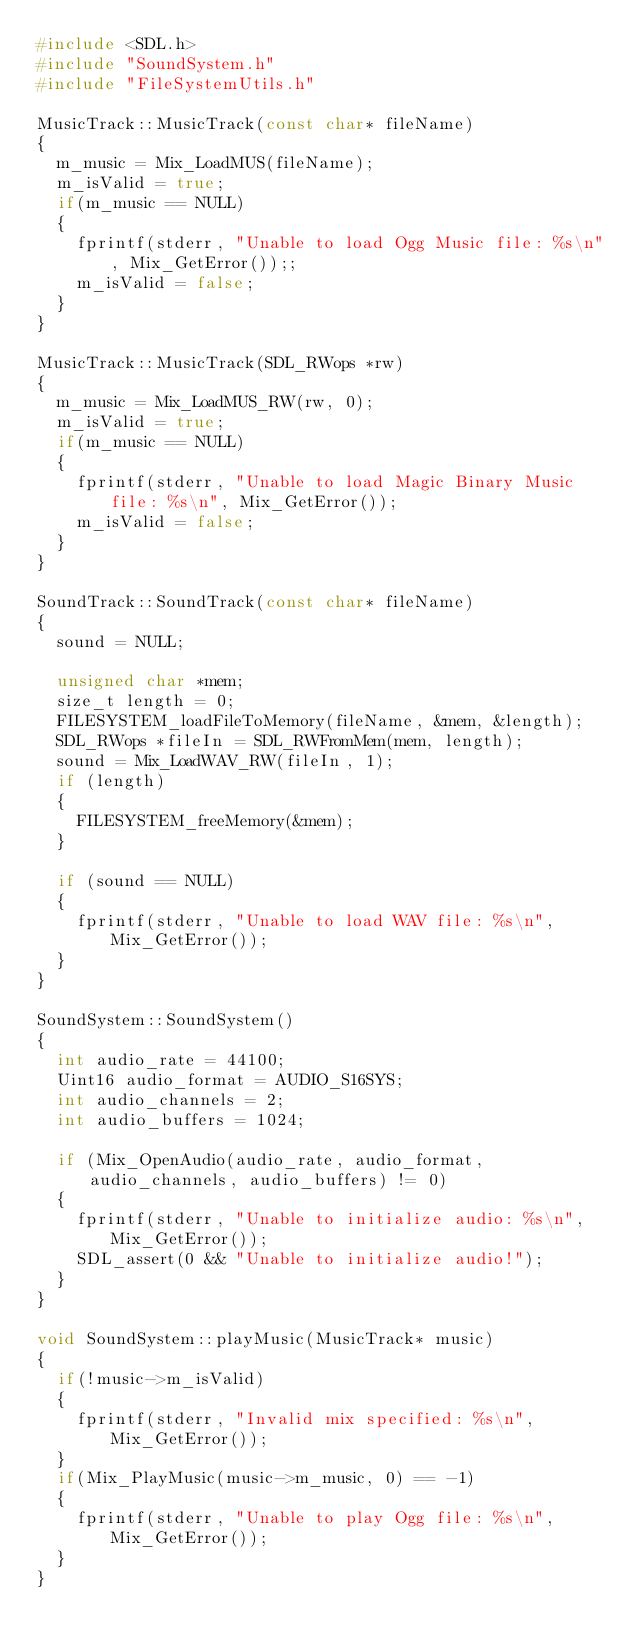<code> <loc_0><loc_0><loc_500><loc_500><_C++_>#include <SDL.h>
#include "SoundSystem.h"
#include "FileSystemUtils.h"

MusicTrack::MusicTrack(const char* fileName)
{
	m_music = Mix_LoadMUS(fileName);
	m_isValid = true;
	if(m_music == NULL)
	{
		fprintf(stderr, "Unable to load Ogg Music file: %s\n", Mix_GetError());;
		m_isValid = false;
	}
}

MusicTrack::MusicTrack(SDL_RWops *rw)
{
	m_music = Mix_LoadMUS_RW(rw, 0);
	m_isValid = true;
	if(m_music == NULL)
	{
		fprintf(stderr, "Unable to load Magic Binary Music file: %s\n", Mix_GetError());
		m_isValid = false;
	}
}

SoundTrack::SoundTrack(const char* fileName)
{
	sound = NULL;

	unsigned char *mem;
	size_t length = 0;
	FILESYSTEM_loadFileToMemory(fileName, &mem, &length);
	SDL_RWops *fileIn = SDL_RWFromMem(mem, length);
	sound = Mix_LoadWAV_RW(fileIn, 1);
	if (length)
	{
		FILESYSTEM_freeMemory(&mem);
	}

	if (sound == NULL)
	{
		fprintf(stderr, "Unable to load WAV file: %s\n", Mix_GetError());
	}
}

SoundSystem::SoundSystem()
{
	int audio_rate = 44100;
	Uint16 audio_format = AUDIO_S16SYS;
	int audio_channels = 2;
	int audio_buffers = 1024;

	if (Mix_OpenAudio(audio_rate, audio_format, audio_channels, audio_buffers) != 0)
	{
		fprintf(stderr, "Unable to initialize audio: %s\n", Mix_GetError());
		SDL_assert(0 && "Unable to initialize audio!");
	}
}

void SoundSystem::playMusic(MusicTrack* music)
{
	if(!music->m_isValid)
	{
		fprintf(stderr, "Invalid mix specified: %s\n", Mix_GetError());
	}
	if(Mix_PlayMusic(music->m_music, 0) == -1)
	{
		fprintf(stderr, "Unable to play Ogg file: %s\n", Mix_GetError());
	}
}
</code> 